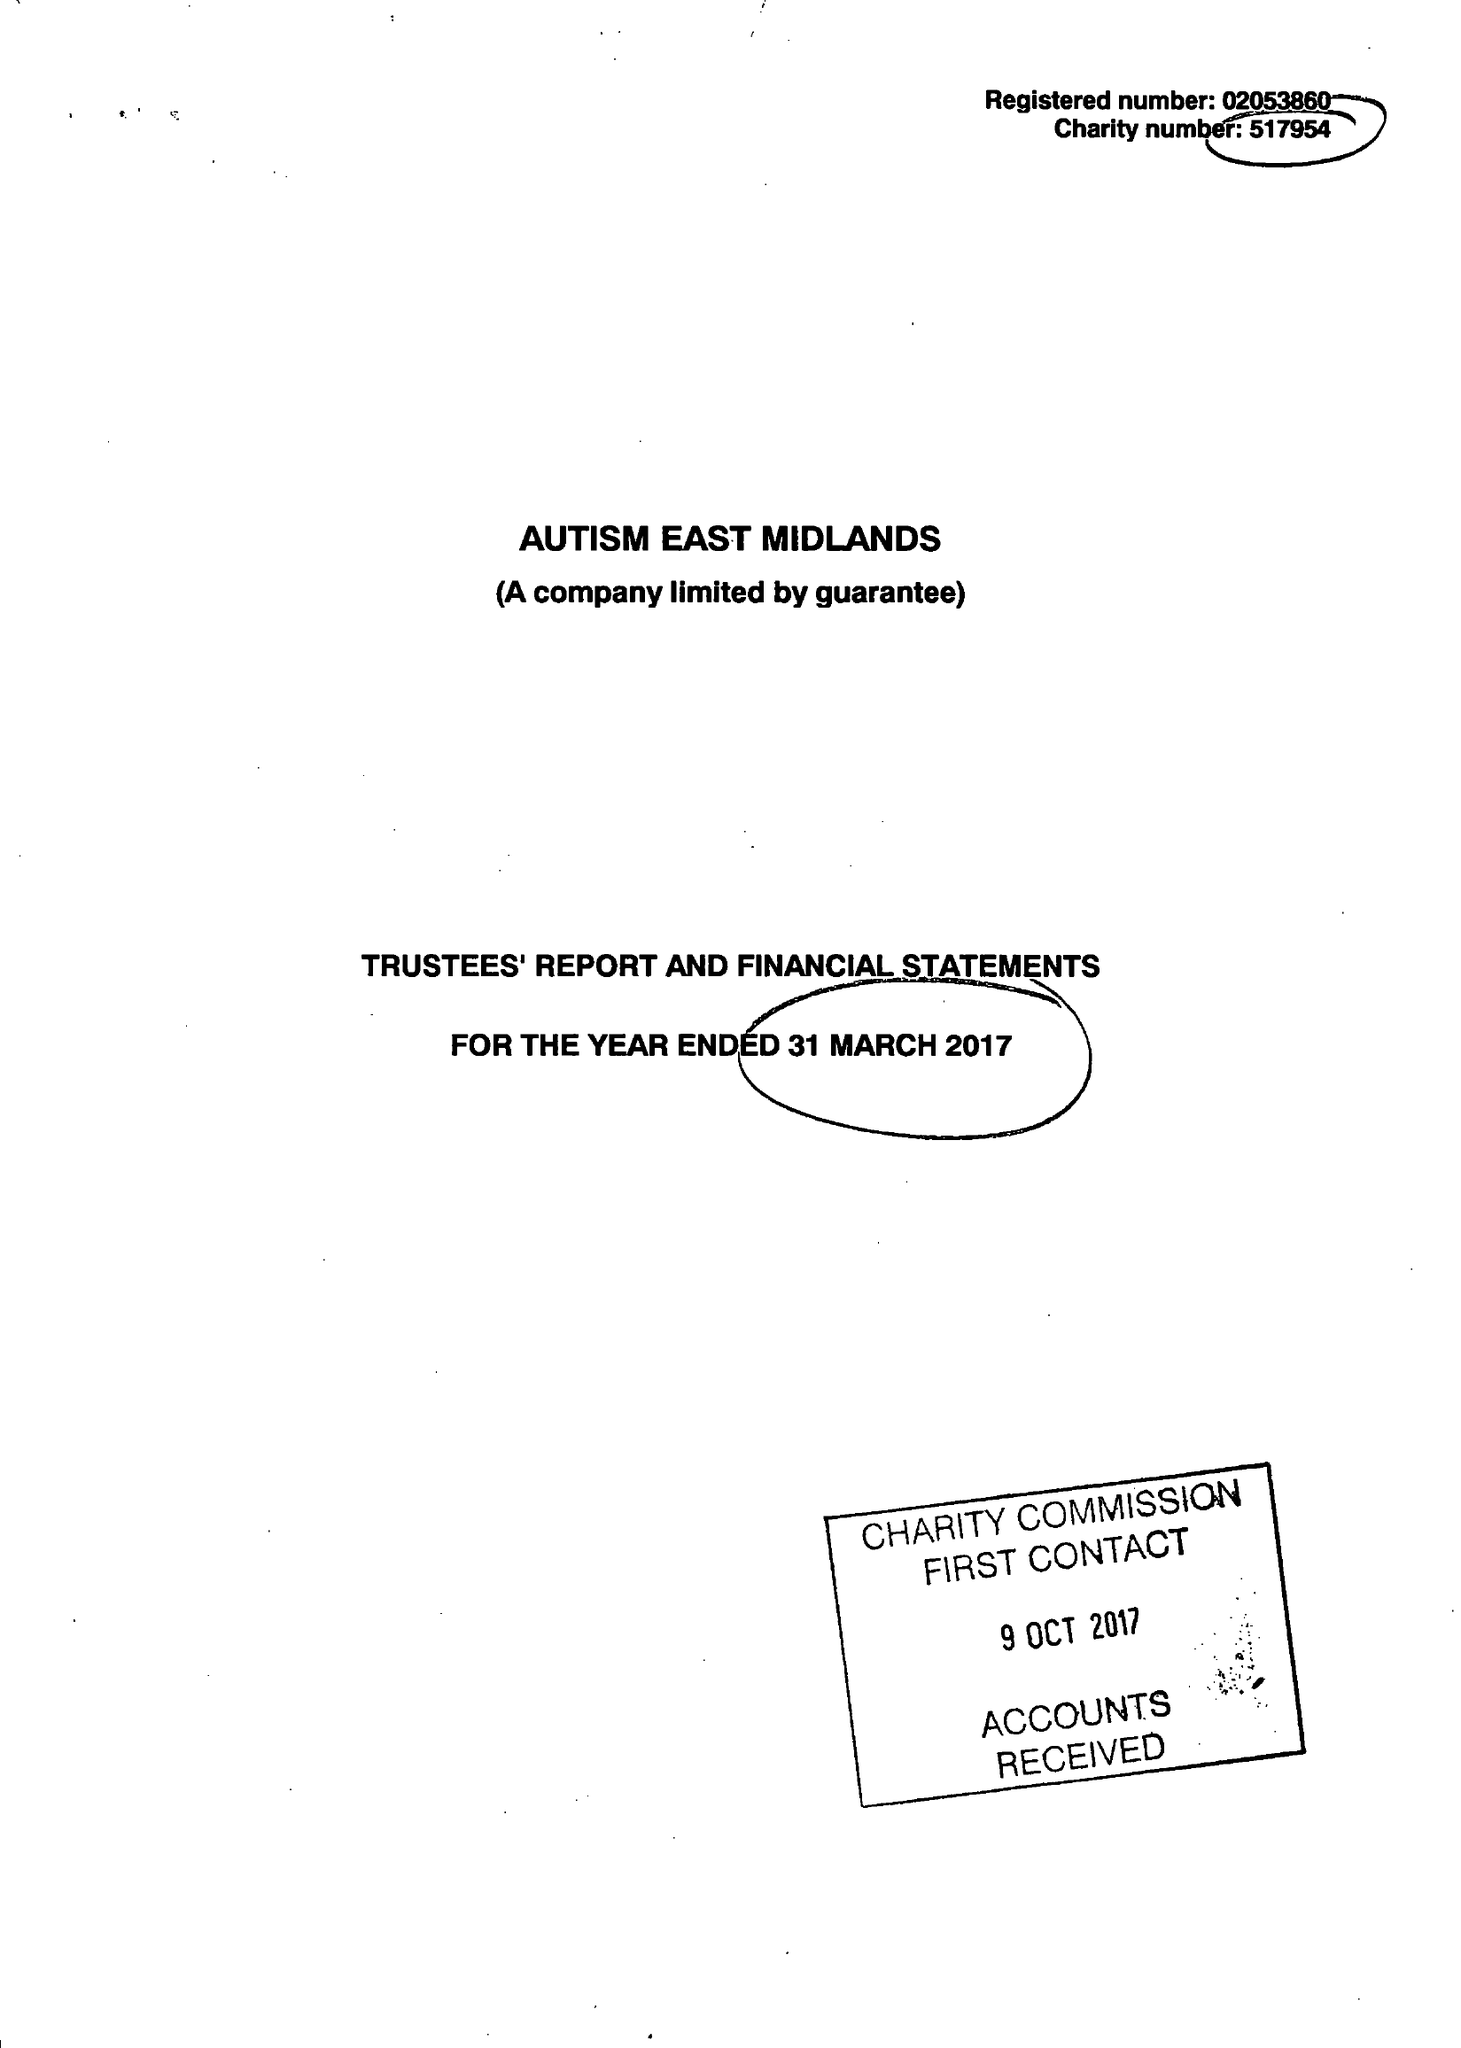What is the value for the address__street_line?
Answer the question using a single word or phrase. MORVEN STREET 